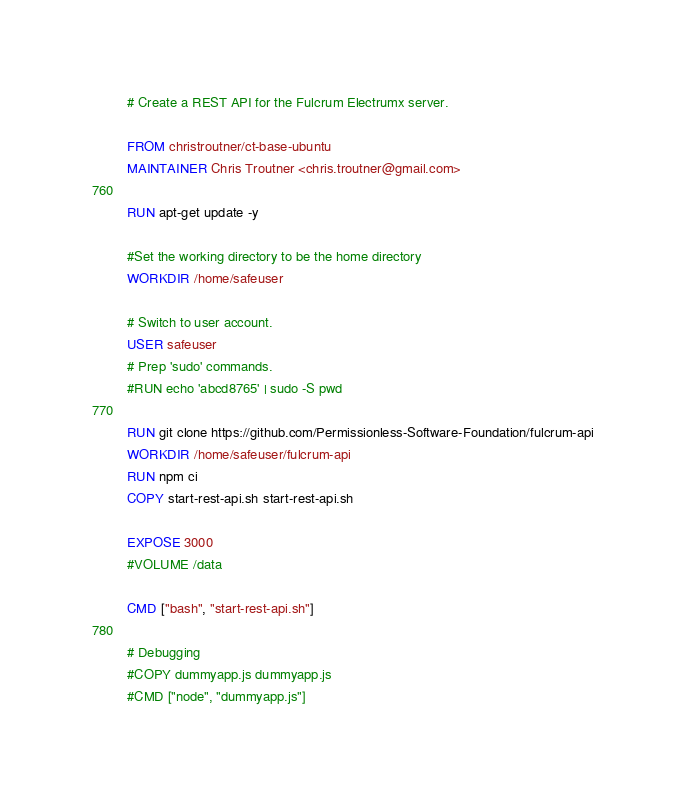<code> <loc_0><loc_0><loc_500><loc_500><_Dockerfile_># Create a REST API for the Fulcrum Electrumx server.

FROM christroutner/ct-base-ubuntu
MAINTAINER Chris Troutner <chris.troutner@gmail.com>

RUN apt-get update -y

#Set the working directory to be the home directory
WORKDIR /home/safeuser

# Switch to user account.
USER safeuser
# Prep 'sudo' commands.
#RUN echo 'abcd8765' | sudo -S pwd

RUN git clone https://github.com/Permissionless-Software-Foundation/fulcrum-api
WORKDIR /home/safeuser/fulcrum-api
RUN npm ci
COPY start-rest-api.sh start-rest-api.sh

EXPOSE 3000
#VOLUME /data

CMD ["bash", "start-rest-api.sh"]

# Debugging
#COPY dummyapp.js dummyapp.js
#CMD ["node", "dummyapp.js"]
</code> 